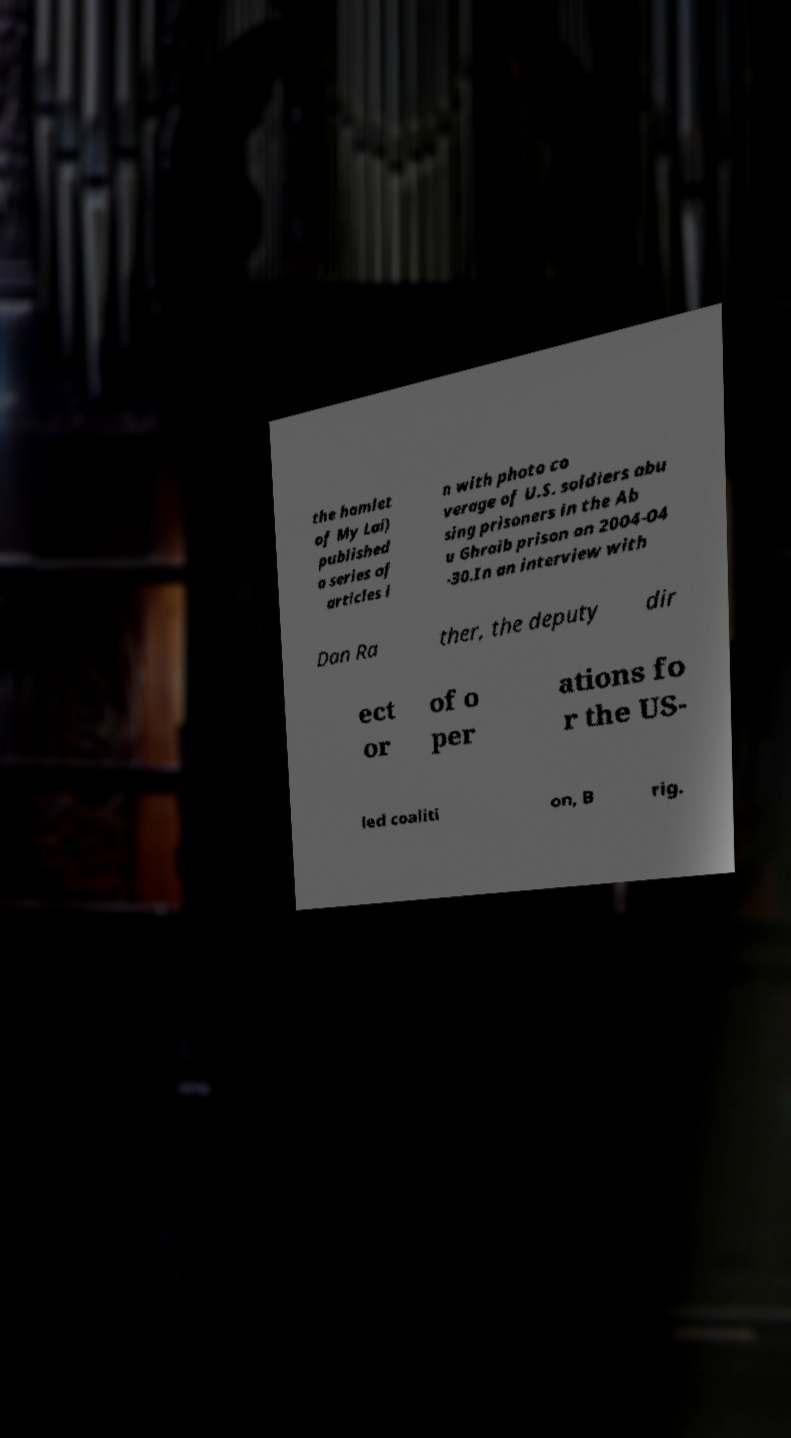Please read and relay the text visible in this image. What does it say? the hamlet of My Lai) published a series of articles i n with photo co verage of U.S. soldiers abu sing prisoners in the Ab u Ghraib prison on 2004-04 -30.In an interview with Dan Ra ther, the deputy dir ect or of o per ations fo r the US- led coaliti on, B rig. 